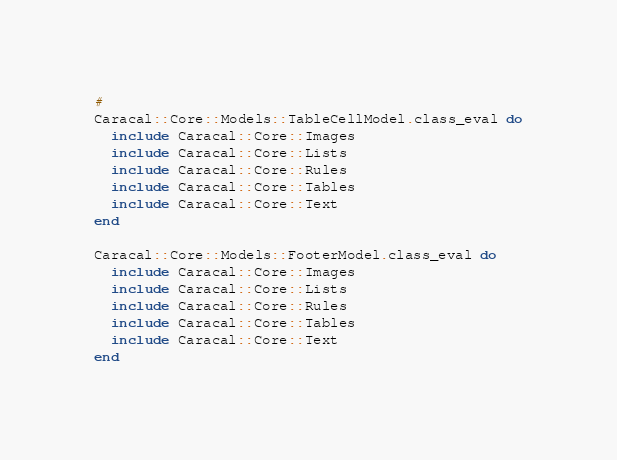<code> <loc_0><loc_0><loc_500><loc_500><_Ruby_>#
Caracal::Core::Models::TableCellModel.class_eval do
  include Caracal::Core::Images
  include Caracal::Core::Lists
  include Caracal::Core::Rules
  include Caracal::Core::Tables
  include Caracal::Core::Text
end

Caracal::Core::Models::FooterModel.class_eval do
  include Caracal::Core::Images
  include Caracal::Core::Lists
  include Caracal::Core::Rules
  include Caracal::Core::Tables
  include Caracal::Core::Text
end</code> 